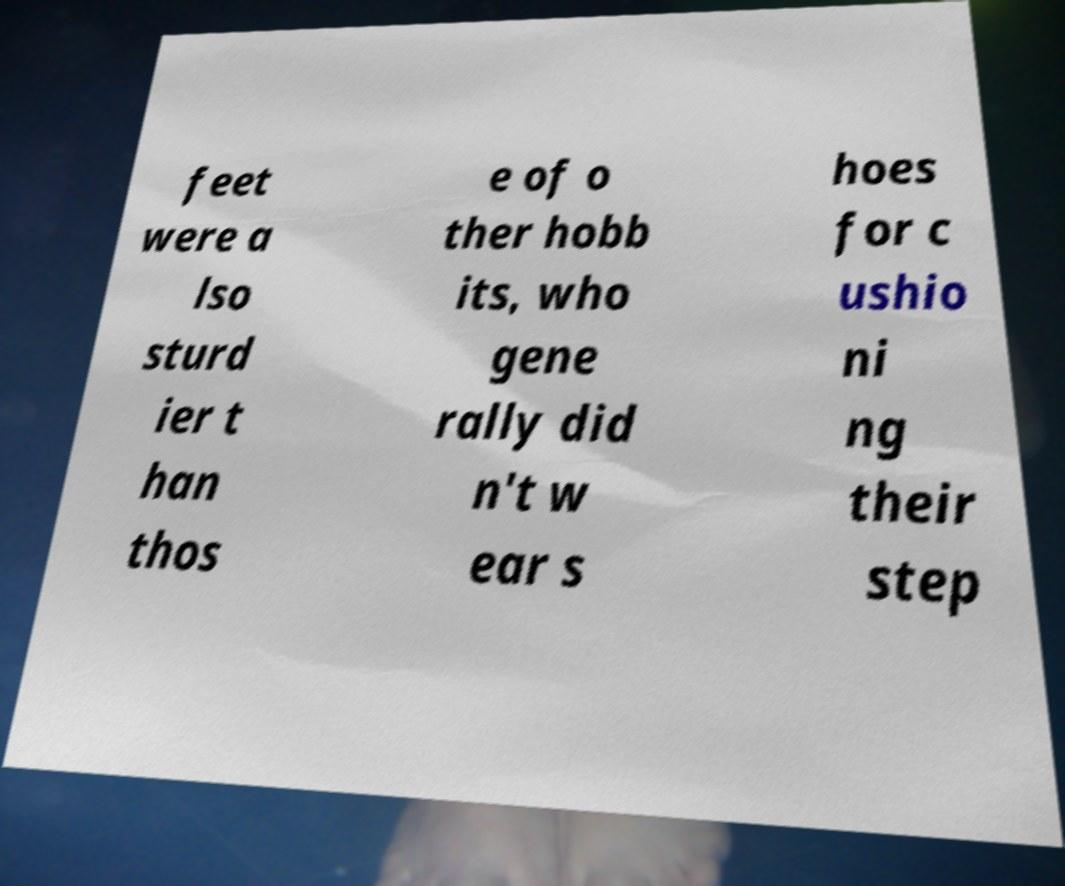Please read and relay the text visible in this image. What does it say? feet were a lso sturd ier t han thos e of o ther hobb its, who gene rally did n't w ear s hoes for c ushio ni ng their step 